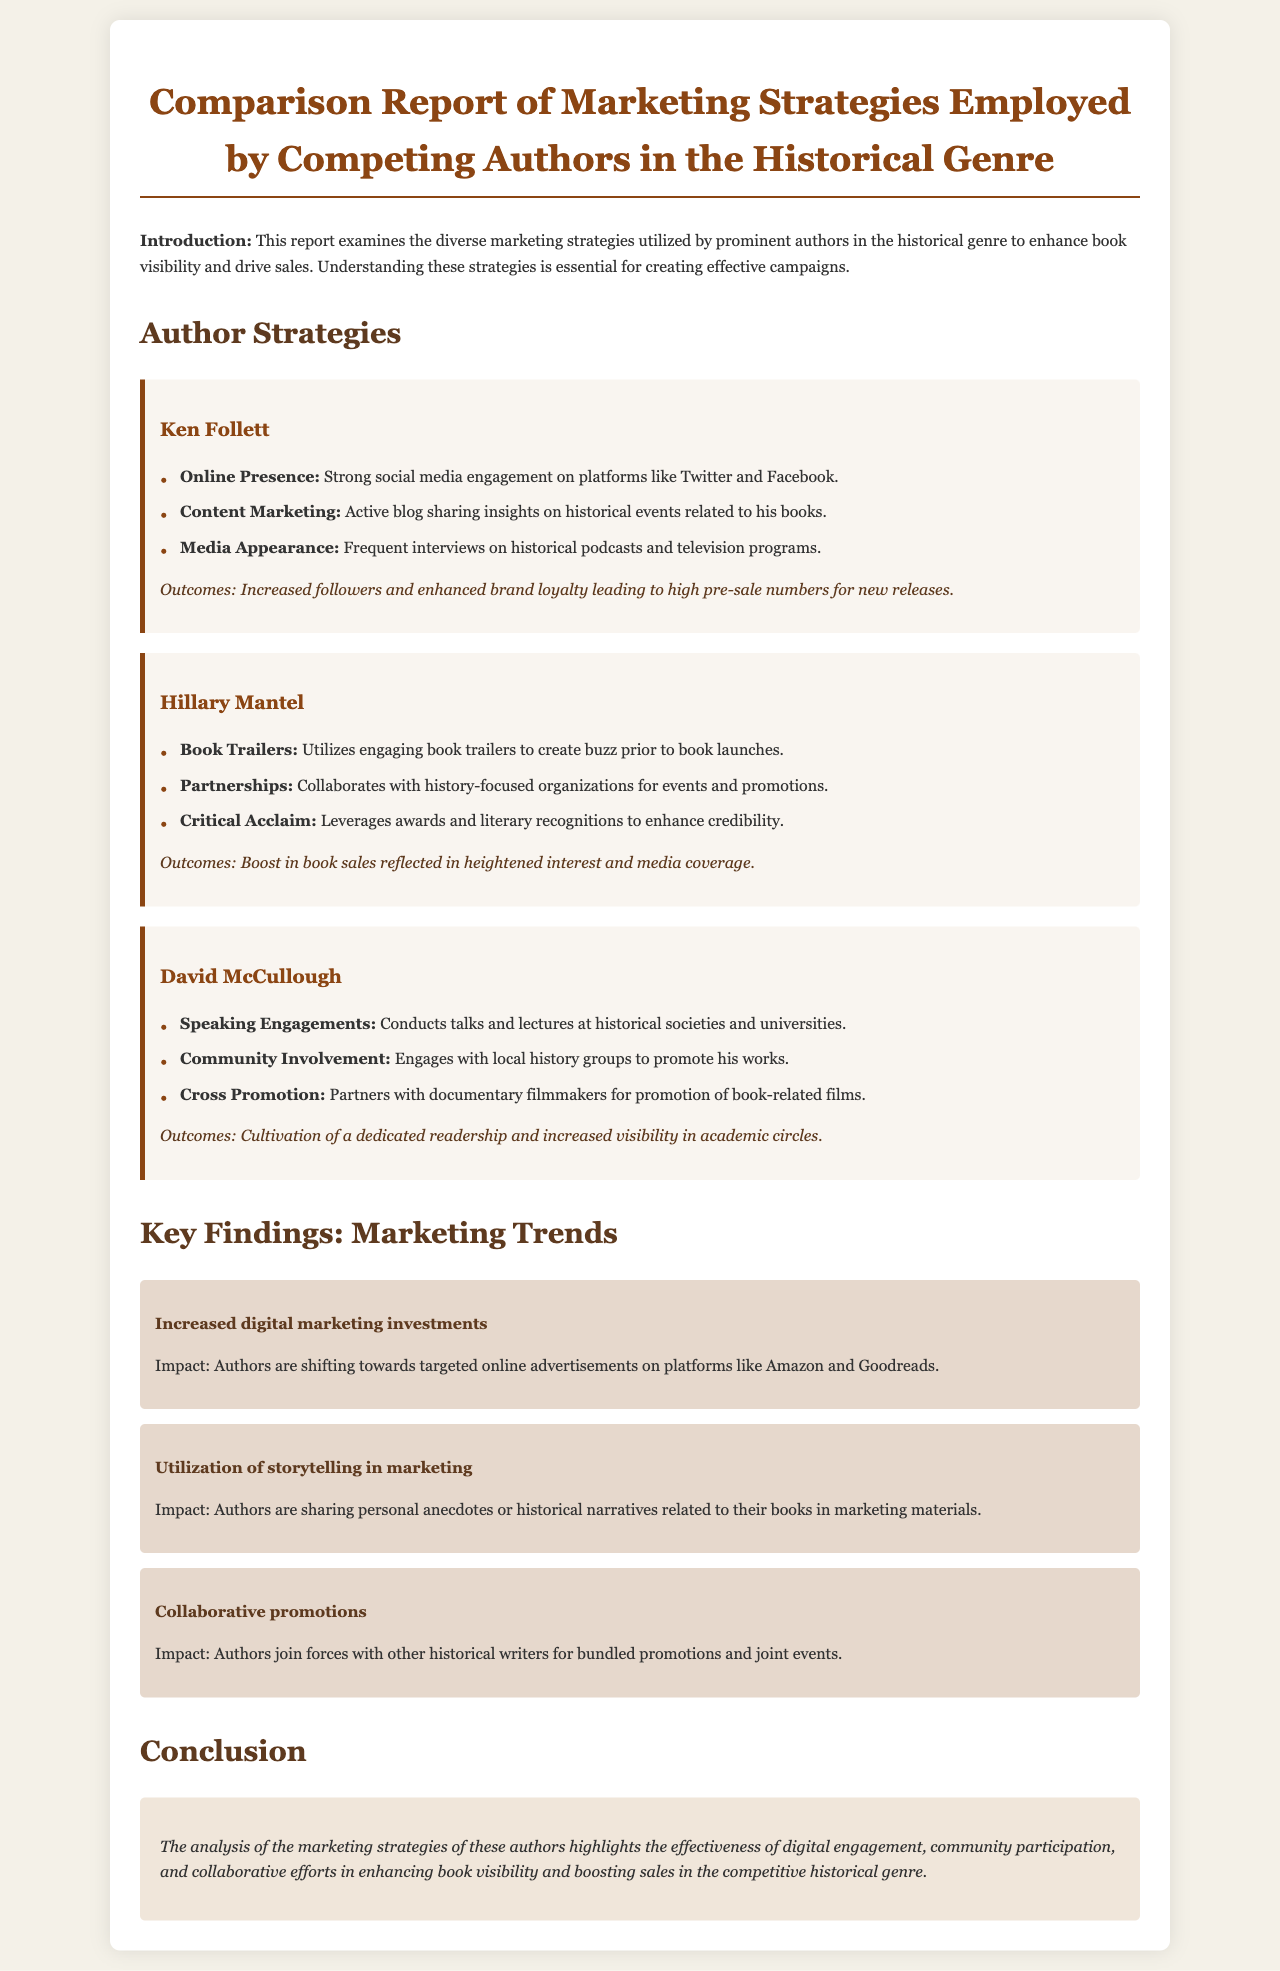What is the title of the report? The title of the report is provided in the heading at the top of the document.
Answer: Comparison Report of Marketing Strategies Employed by Competing Authors in the Historical Genre Who is the author that utilizes engaging book trailers? The author's name is found in the section discussing their specific marketing strategies.
Answer: Hillary Mantel What social media platforms does Ken Follett engage with? The platforms mentioned in the document regarding Ken Follett's online presence are noted in his strategy list.
Answer: Twitter and Facebook How many main authors' strategies are analyzed in the report? The section detailing the author strategies explicitly lists the authors covered in the comparative analysis.
Answer: Three What type of marketing trend involves sharing personal anecdotes? The marketing strategy trend discussed in the report focuses on storytelling.
Answer: Utilization of storytelling in marketing Which author focuses on speaking engagements? This information is found in the section dedicated to the specific author's strategies.
Answer: David McCullough What is a key outcome of Hillary Mantel’s marketing strategies? The outcomes section provides insights into the results of her strategies as detailed in the report.
Answer: Boost in book sales How are authors collaborating according to the trends? The document discusses a specific trend related to authors joining forces for promotions.
Answer: Collaborative promotions 